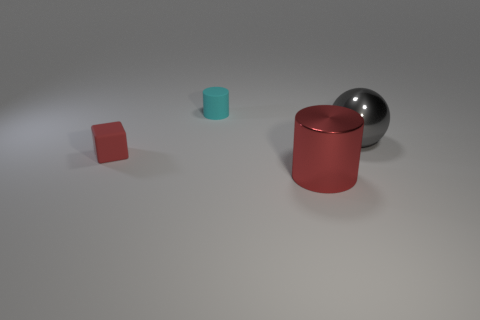What size is the red thing that is in front of the small rubber object that is in front of the cylinder that is behind the red cylinder?
Keep it short and to the point. Large. What is the size of the gray thing that is the same material as the red cylinder?
Your response must be concise. Large. There is a metallic cylinder; does it have the same size as the object to the right of the red metallic cylinder?
Give a very brief answer. Yes. What shape is the red thing that is on the left side of the cyan cylinder?
Ensure brevity in your answer.  Cube. There is a cylinder that is right of the cylinder that is behind the shiny cylinder; are there any red things that are behind it?
Provide a succinct answer. Yes. What material is the large red object that is the same shape as the small cyan thing?
Provide a succinct answer. Metal. What number of balls are either large blue objects or red objects?
Make the answer very short. 0. There is a cylinder that is behind the large gray thing; is it the same size as the red object behind the metal cylinder?
Ensure brevity in your answer.  Yes. There is a red thing on the left side of the small rubber thing behind the gray sphere; what is its material?
Give a very brief answer. Rubber. Are there fewer gray metallic balls that are in front of the big gray object than yellow cubes?
Keep it short and to the point. No. 